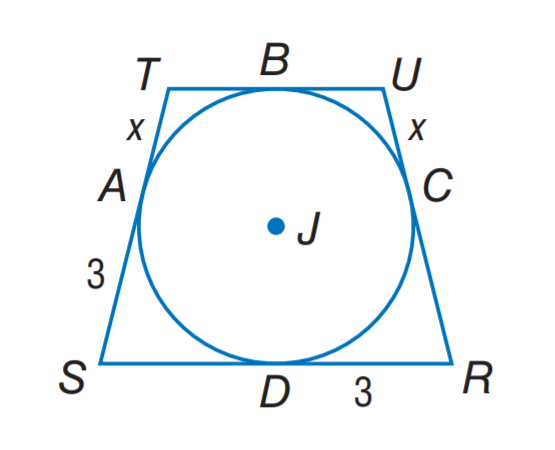Answer the mathemtical geometry problem and directly provide the correct option letter.
Question: Quadrilateral R S T U is circumscribed about \odot J. If the preimeter is 18 units, find x.
Choices: A: 1 B: 1.5 C: 3 D: 4.5 B 